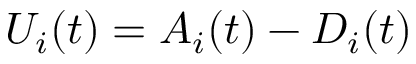<formula> <loc_0><loc_0><loc_500><loc_500>U _ { i } ( t ) = A _ { i } ( t ) - D _ { i } ( t )</formula> 